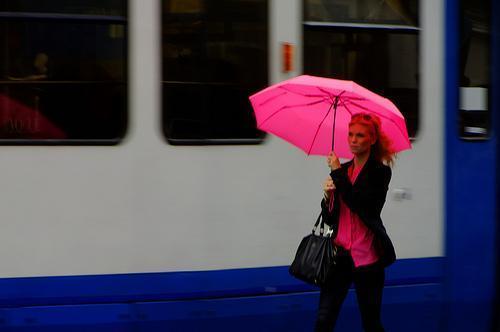How many people?
Give a very brief answer. 1. 